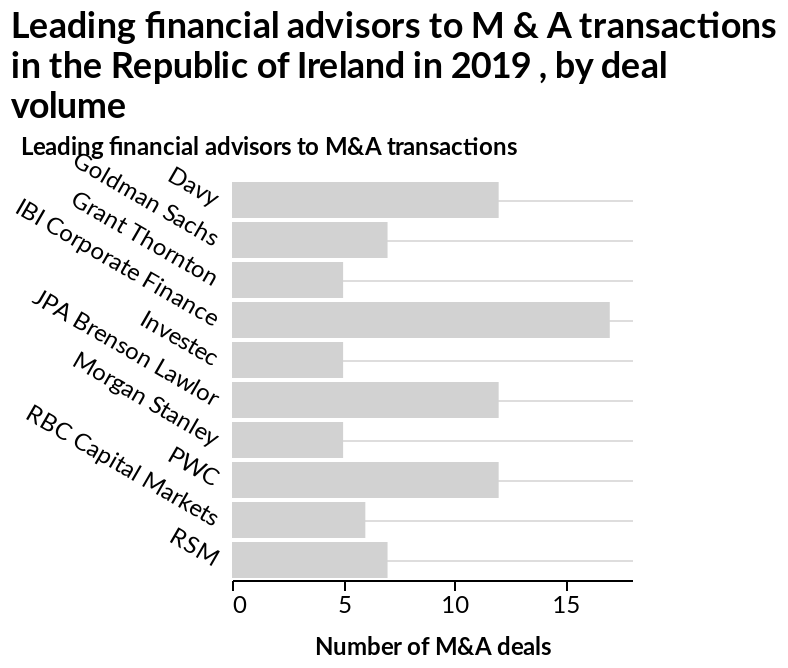<image>
What was the Republic of Ireland's largest number of M&A deals in 2019? IBI corporate finance. What is plotted on the y-axis of the graph? The leading financial advisors to M&A transactions are plotted on the y-axis of the graph. please summary the statistics and relations of the chart IBI corporate finance had the largest number of M&A deals in the Republic of Ireland in 2019. Did IBI corporate finance have the smallest number of M&A deals in the Republic of Ireland in 2019? No.IBI corporate finance had the largest number of M&A deals in the Republic of Ireland in 2019. 